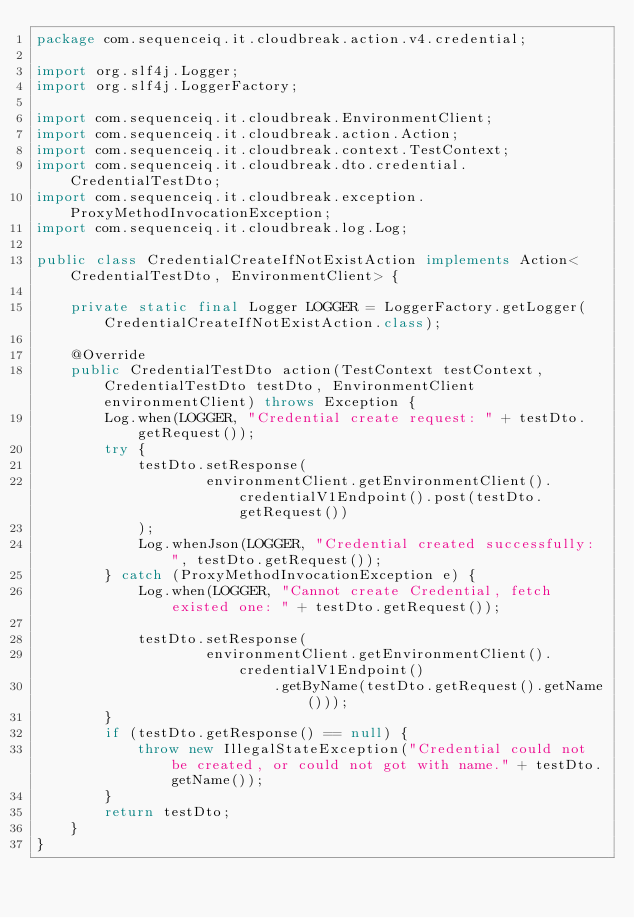<code> <loc_0><loc_0><loc_500><loc_500><_Java_>package com.sequenceiq.it.cloudbreak.action.v4.credential;

import org.slf4j.Logger;
import org.slf4j.LoggerFactory;

import com.sequenceiq.it.cloudbreak.EnvironmentClient;
import com.sequenceiq.it.cloudbreak.action.Action;
import com.sequenceiq.it.cloudbreak.context.TestContext;
import com.sequenceiq.it.cloudbreak.dto.credential.CredentialTestDto;
import com.sequenceiq.it.cloudbreak.exception.ProxyMethodInvocationException;
import com.sequenceiq.it.cloudbreak.log.Log;

public class CredentialCreateIfNotExistAction implements Action<CredentialTestDto, EnvironmentClient> {

    private static final Logger LOGGER = LoggerFactory.getLogger(CredentialCreateIfNotExistAction.class);

    @Override
    public CredentialTestDto action(TestContext testContext, CredentialTestDto testDto, EnvironmentClient environmentClient) throws Exception {
        Log.when(LOGGER, "Credential create request: " + testDto.getRequest());
        try {
            testDto.setResponse(
                    environmentClient.getEnvironmentClient().credentialV1Endpoint().post(testDto.getRequest())
            );
            Log.whenJson(LOGGER, "Credential created successfully: ", testDto.getRequest());
        } catch (ProxyMethodInvocationException e) {
            Log.when(LOGGER, "Cannot create Credential, fetch existed one: " + testDto.getRequest());

            testDto.setResponse(
                    environmentClient.getEnvironmentClient().credentialV1Endpoint()
                            .getByName(testDto.getRequest().getName()));
        }
        if (testDto.getResponse() == null) {
            throw new IllegalStateException("Credential could not be created, or could not got with name." + testDto.getName());
        }
        return testDto;
    }
}
</code> 